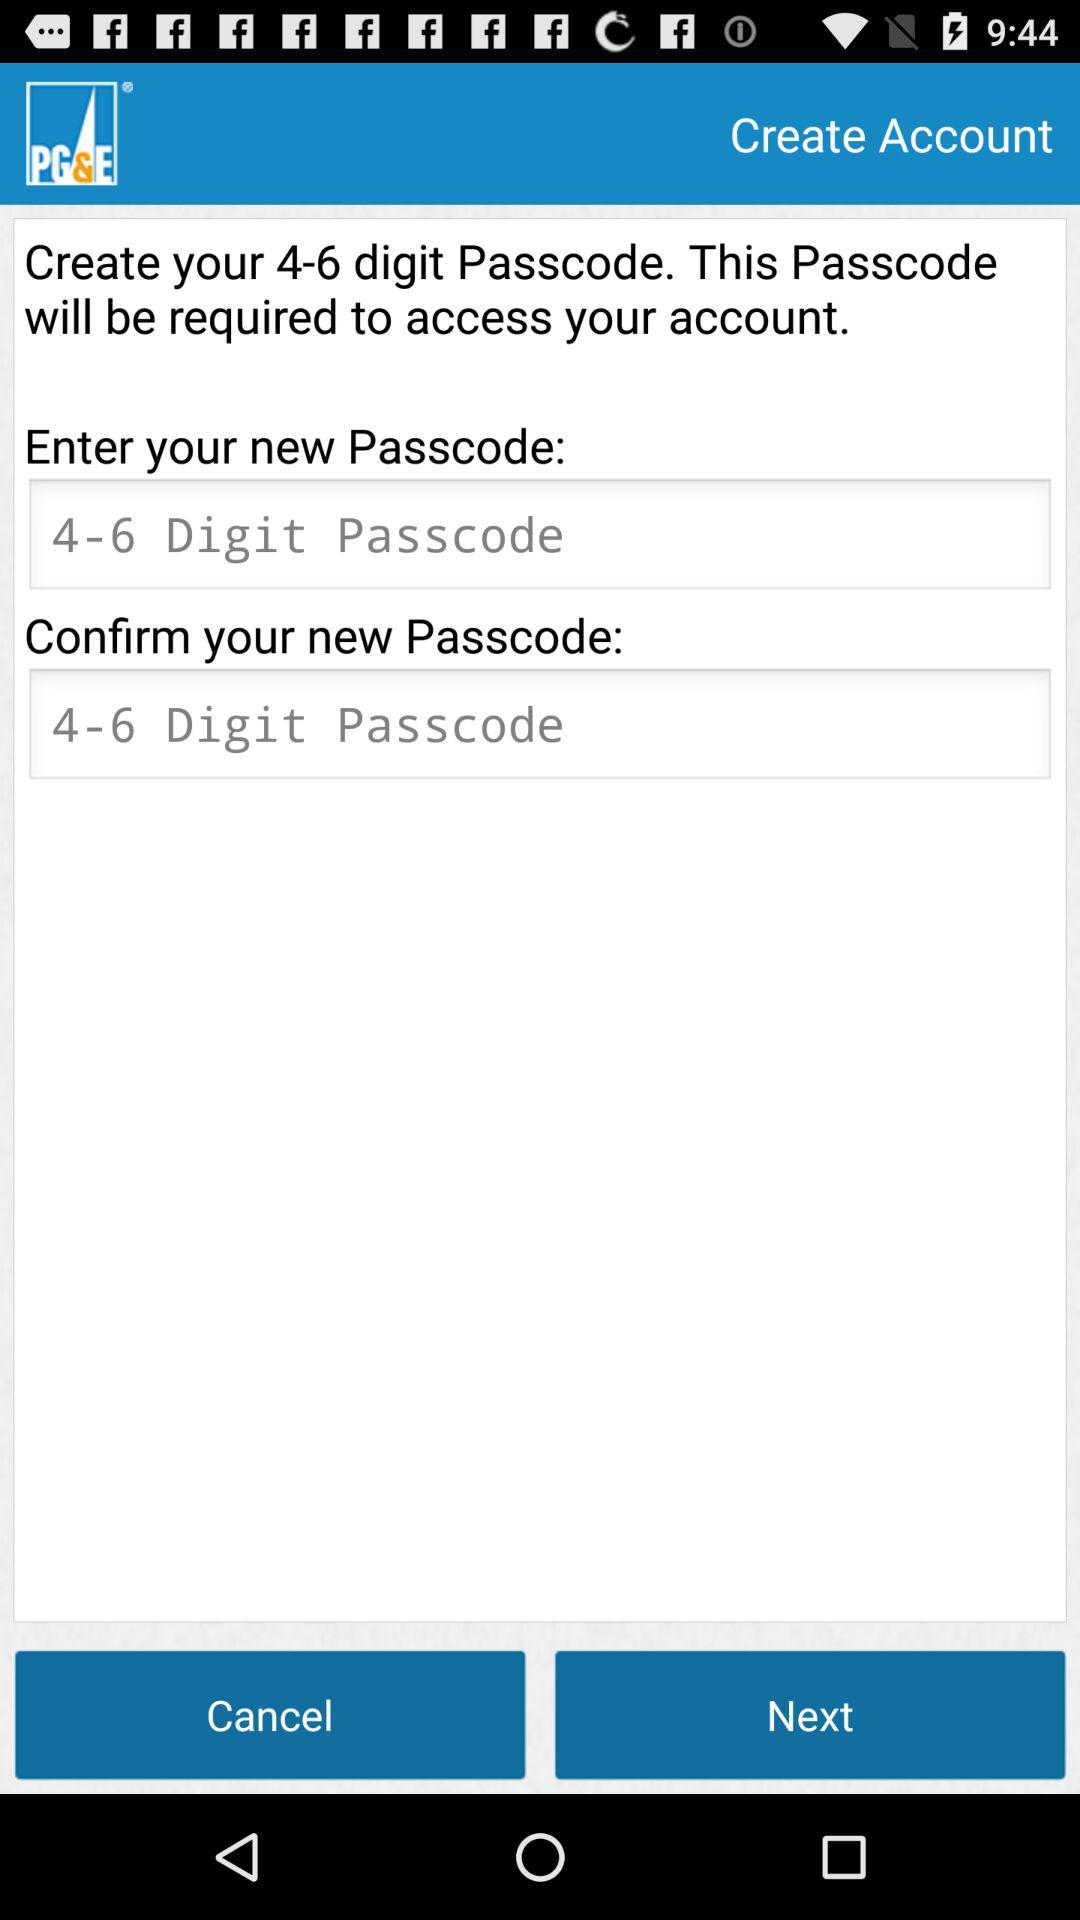How many digits are required to create a Passcode? The number of digits required to create a Passcode is 4 to 6. 